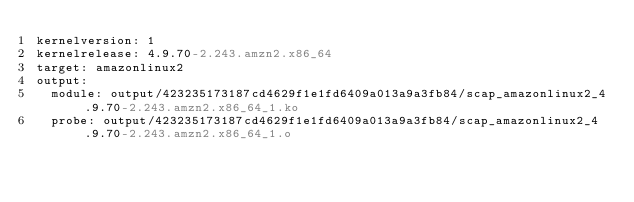Convert code to text. <code><loc_0><loc_0><loc_500><loc_500><_YAML_>kernelversion: 1
kernelrelease: 4.9.70-2.243.amzn2.x86_64
target: amazonlinux2
output:
  module: output/423235173187cd4629f1e1fd6409a013a9a3fb84/scap_amazonlinux2_4.9.70-2.243.amzn2.x86_64_1.ko
  probe: output/423235173187cd4629f1e1fd6409a013a9a3fb84/scap_amazonlinux2_4.9.70-2.243.amzn2.x86_64_1.o
</code> 